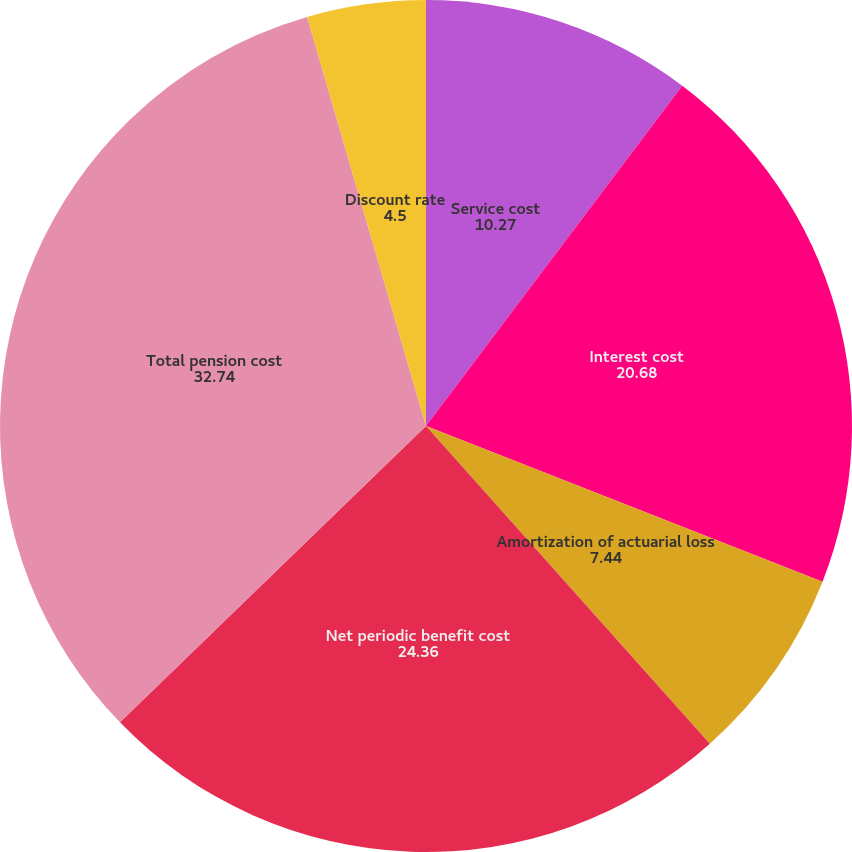<chart> <loc_0><loc_0><loc_500><loc_500><pie_chart><fcel>Service cost<fcel>Interest cost<fcel>Amortization of actuarial loss<fcel>Net periodic benefit cost<fcel>Total pension cost<fcel>Discount rate<nl><fcel>10.27%<fcel>20.68%<fcel>7.44%<fcel>24.36%<fcel>32.74%<fcel>4.5%<nl></chart> 